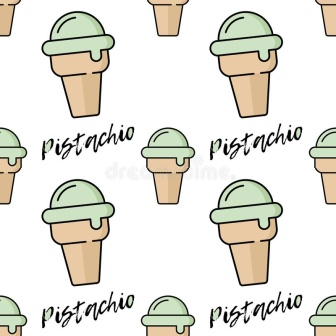What do you think the design intention was behind this image? The design intention behind this image appears to be to create a visually captivating and enjoyable pattern that appeals to both the eye and the taste buds. The use of pistachio ice cream, with its vibrant green color, set against the light brown of the cones, creates a pleasing contrast that is inviting and refreshing. The repetition and orderly arrangement of the cones help to form a harmonious and rhythmic pattern, while the inclusion of the word 'Pistachio' above and below each cone reinforces the theme and adds a fun textual element. Overall, the design aims to evoke a sense of joy, sweetness, and playfulness, making it a delightful visual experience. 